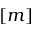<formula> <loc_0><loc_0><loc_500><loc_500>[ m ]</formula> 